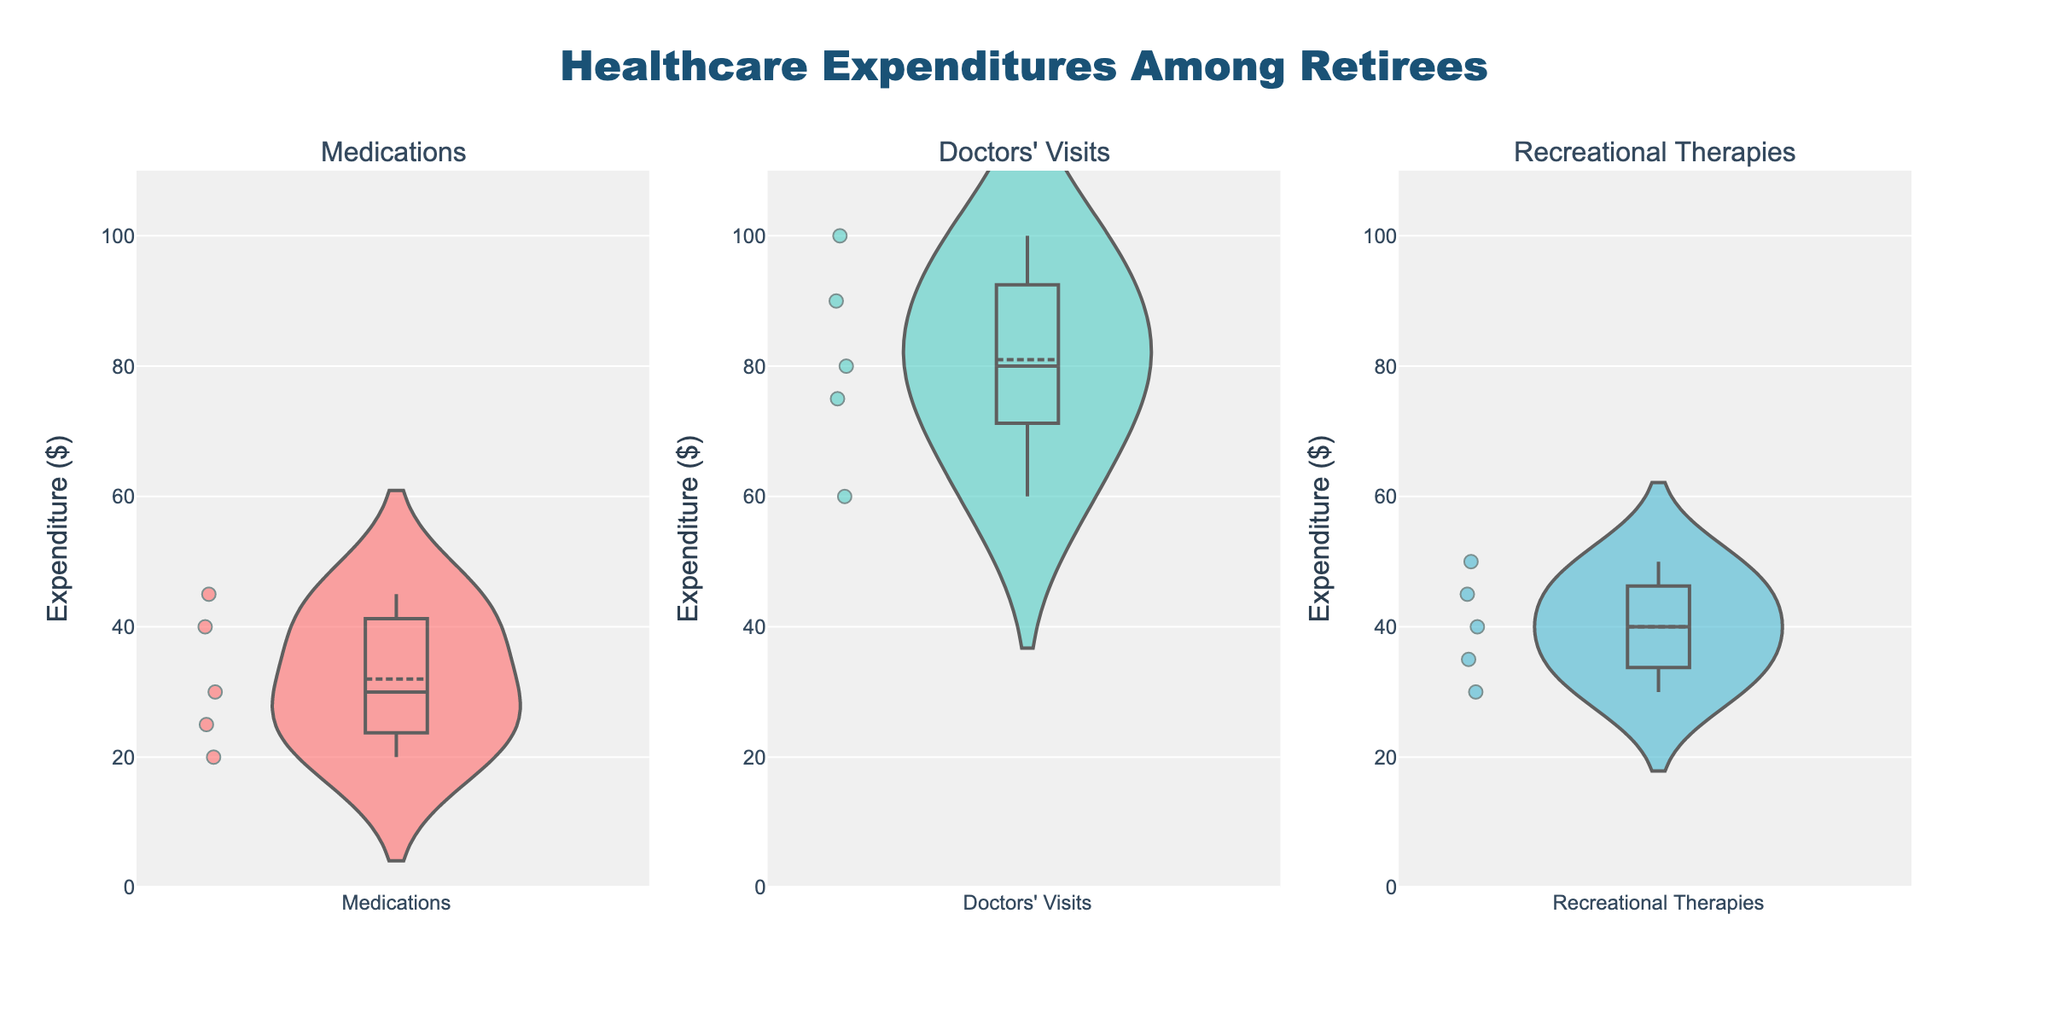How many categories are depicted in the figure? The title of the subplots provides the number of unique categories. By observing each subplot title, one can count the categories.
Answer: 3 What color represents the 'Doctors' Visits' category in the figure? The unique custom color is assigned for each category. By observing the 'Doctors' Visits' subplot, one can identify the color.
Answer: Turquoise Which category shows the highest average expenditure? By comparing the mean lines across all subplots, the category with the highest mean line indicates the highest average expenditure.
Answer: Doctors' Visits What is the range of expenditures for 'Recreational Therapies'? Observing the minimum and maximum points on the 'Recreational Therapies' subplot indicates the expenditure range.
Answer: $30 to $50 Which medication has the lowest expenditure? By looking at the points and their corresponding values in the 'Medications' subplot, one can identify the medication with the lowest expenditure.
Answer: Omeprazole How many medications have expenditures above $30? Counting the number of points above the $30 line in the 'Medications' subplot will answer this question.
Answer: 3 Are the expenditures for 'Doctors' Visits' generally higher than those for 'Recreational Therapies'? By comparing the overall spread and positions of the points in both subplots, it's visible that 'Doctors' Visits' tend to have higher expenditures.
Answer: Yes What is the median expenditure for 'Doctors' Visits'? The median line (central line) in the box within the violin plot represents the median expenditure in the 'Doctors' Visits' subplot.
Answer: $80 How does the spread of expenditures for 'Medications' compare to 'Recreational Therapies'? The width of the violin plots and the dispersion of points provide insight into the variability or spread of expenditures for each category.
Answer: 'Medications' has a wider spread Which category exhibits the least variability in expenditures? By comparing the tightness and spread of the violin plots, the category with the narrowest plot indicates the least variability.
Answer: Medications 